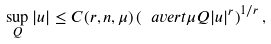Convert formula to latex. <formula><loc_0><loc_0><loc_500><loc_500>\sup _ { Q } | u | \leq C ( r , n , \mu ) \left ( \ a v e r t { \mu Q } | u | ^ { r } \right ) ^ { 1 / r } ,</formula> 